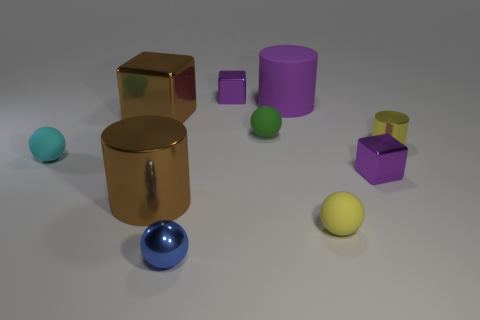There is another large object that is the same shape as the purple rubber object; what is it made of?
Provide a succinct answer. Metal. How many balls have the same size as the brown shiny block?
Ensure brevity in your answer.  0. What is the shape of the large purple object?
Give a very brief answer. Cylinder. What size is the cylinder that is both in front of the small green rubber thing and right of the small green rubber object?
Make the answer very short. Small. There is a small purple block behind the cyan object; what is its material?
Give a very brief answer. Metal. There is a small metallic cylinder; does it have the same color as the large metal cylinder that is to the left of the small yellow matte thing?
Provide a succinct answer. No. What number of objects are tiny purple shiny objects that are in front of the small shiny cylinder or matte spheres that are right of the blue metal thing?
Offer a terse response. 3. There is a small metallic thing that is both to the left of the large purple rubber thing and in front of the large metallic block; what color is it?
Your answer should be compact. Blue. Are there more large cyan blocks than yellow things?
Ensure brevity in your answer.  No. There is a rubber thing that is on the left side of the blue shiny thing; is it the same shape as the small yellow metal object?
Keep it short and to the point. No. 